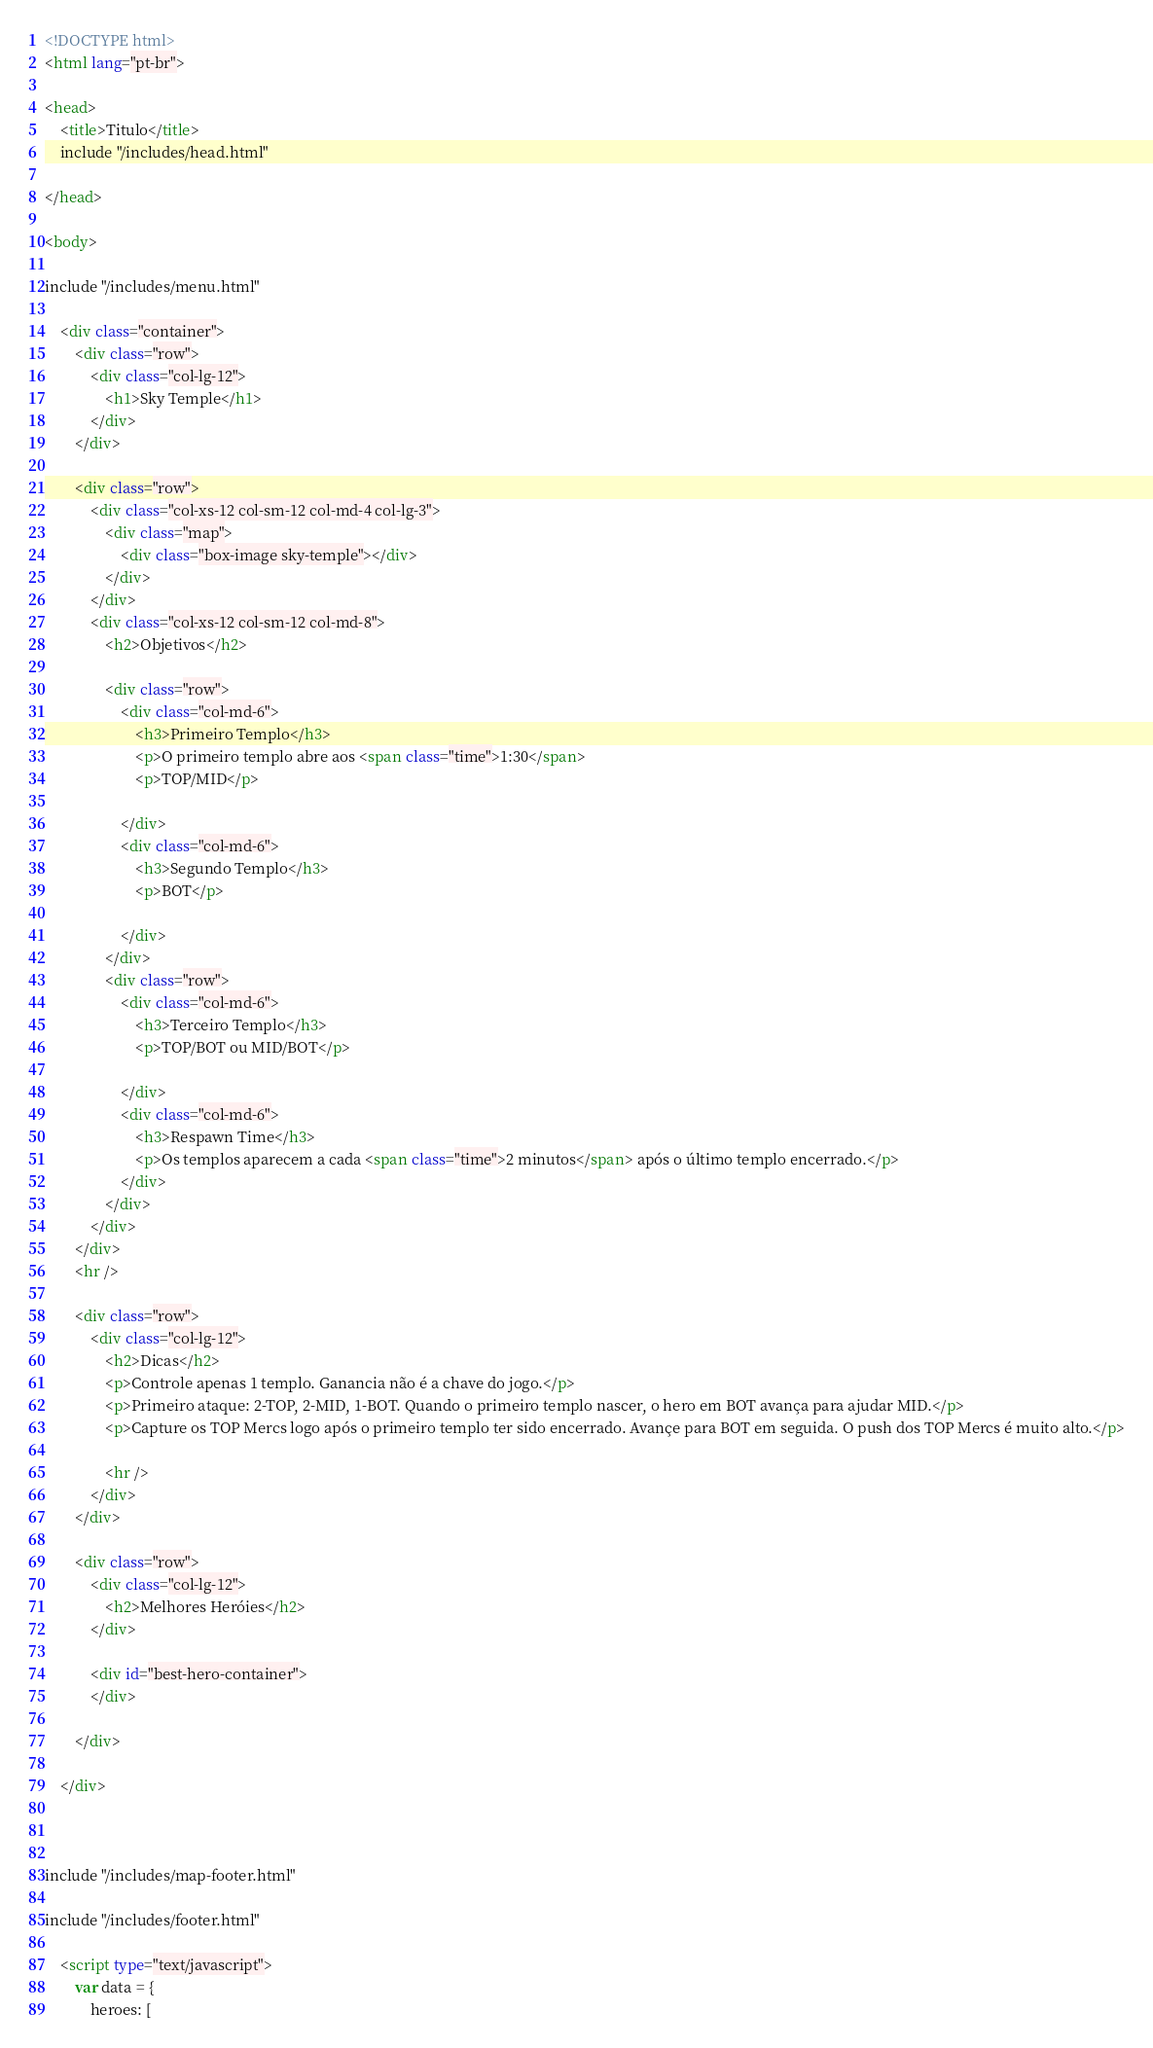<code> <loc_0><loc_0><loc_500><loc_500><_HTML_><!DOCTYPE html>
<html lang="pt-br">

<head>
    <title>Titulo</title>
    include "/includes/head.html"

</head>

<body>

include "/includes/menu.html"

    <div class="container">
        <div class="row">
            <div class="col-lg-12">
                <h1>Sky Temple</h1>
            </div>
        </div>

        <div class="row">
            <div class="col-xs-12 col-sm-12 col-md-4 col-lg-3">
                <div class="map">
                    <div class="box-image sky-temple"></div>
                </div>
            </div>
            <div class="col-xs-12 col-sm-12 col-md-8">
                <h2>Objetivos</h2>

                <div class="row">
                    <div class="col-md-6">
                        <h3>Primeiro Templo</h3>
                        <p>O primeiro templo abre aos <span class="time">1:30</span>
                        <p>TOP/MID</p>

                    </div>
                    <div class="col-md-6">
                        <h3>Segundo Templo</h3>
                        <p>BOT</p>

                    </div>
                </div>
                <div class="row">
                    <div class="col-md-6">
                        <h3>Terceiro Templo</h3>
                        <p>TOP/BOT ou MID/BOT</p>

                    </div>
                    <div class="col-md-6">
                        <h3>Respawn Time</h3>
                        <p>Os templos aparecem a cada <span class="time">2 minutos</span> após o último templo encerrado.</p>
                    </div>
                </div>
            </div>
        </div>
        <hr />

        <div class="row">
            <div class="col-lg-12">
                <h2>Dicas</h2>
                <p>Controle apenas 1 templo. Ganancia não é a chave do jogo.</p>
                <p>Primeiro ataque: 2-TOP, 2-MID, 1-BOT. Quando o primeiro templo nascer, o hero em BOT avança para ajudar MID.</p>
                <p>Capture os TOP Mercs logo após o primeiro templo ter sido encerrado. Avançe para BOT em seguida. O push dos TOP Mercs é muito alto.</p>

                <hr />
            </div>
        </div>

        <div class="row">
            <div class="col-lg-12">
                <h2>Melhores Heróies</h2>
            </div>

            <div id="best-hero-container">
            </div>

        </div>

    </div>



include "/includes/map-footer.html"

include "/includes/footer.html"

    <script type="text/javascript">
        var data = {
            heroes: [</code> 